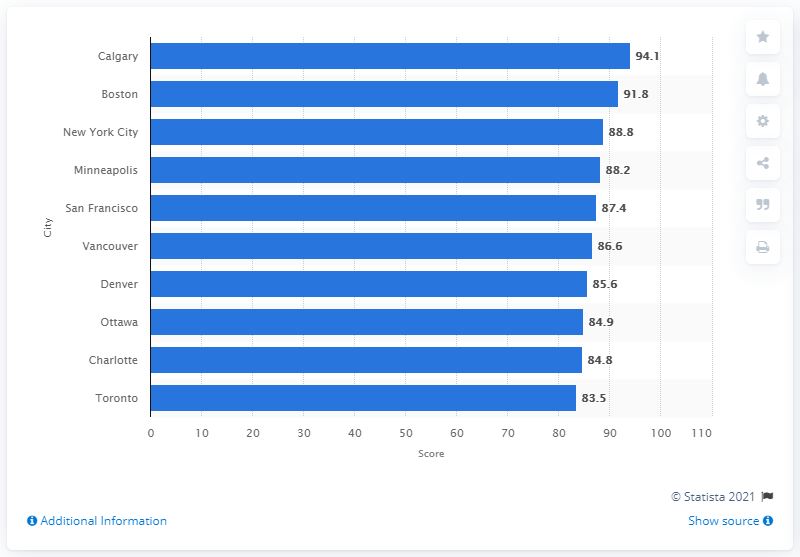Indicate a few pertinent items in this graphic. Denver's score was 85.6 out of 100. 